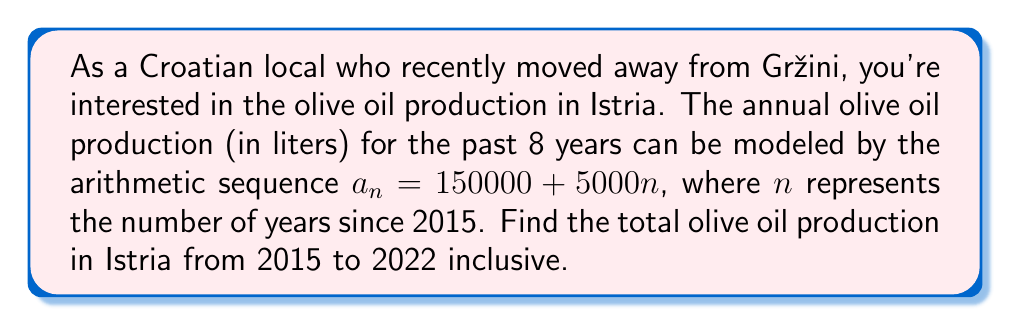Teach me how to tackle this problem. To solve this problem, we need to find the partial sum of the arithmetic sequence for the first 8 terms. Let's approach this step-by-step:

1) First, recall the formula for the sum of an arithmetic sequence:
   $$S_n = \frac{n}{2}(a_1 + a_n)$$
   where $S_n$ is the sum of the first $n$ terms, $a_1$ is the first term, and $a_n$ is the nth term.

2) In our sequence, $a_n = 150000 + 5000n$
   So, $a_1 = 150000 + 5000(1) = 155000$
   And $a_8 = 150000 + 5000(8) = 190000$

3) We want the sum of the first 8 terms, so $n = 8$

4) Now, let's substitute these values into our formula:
   $$S_8 = \frac{8}{2}(155000 + 190000)$$

5) Simplify:
   $$S_8 = 4(345000) = 1380000$$

Therefore, the total olive oil production from 2015 to 2022 is 1,380,000 liters.
Answer: 1,380,000 liters 